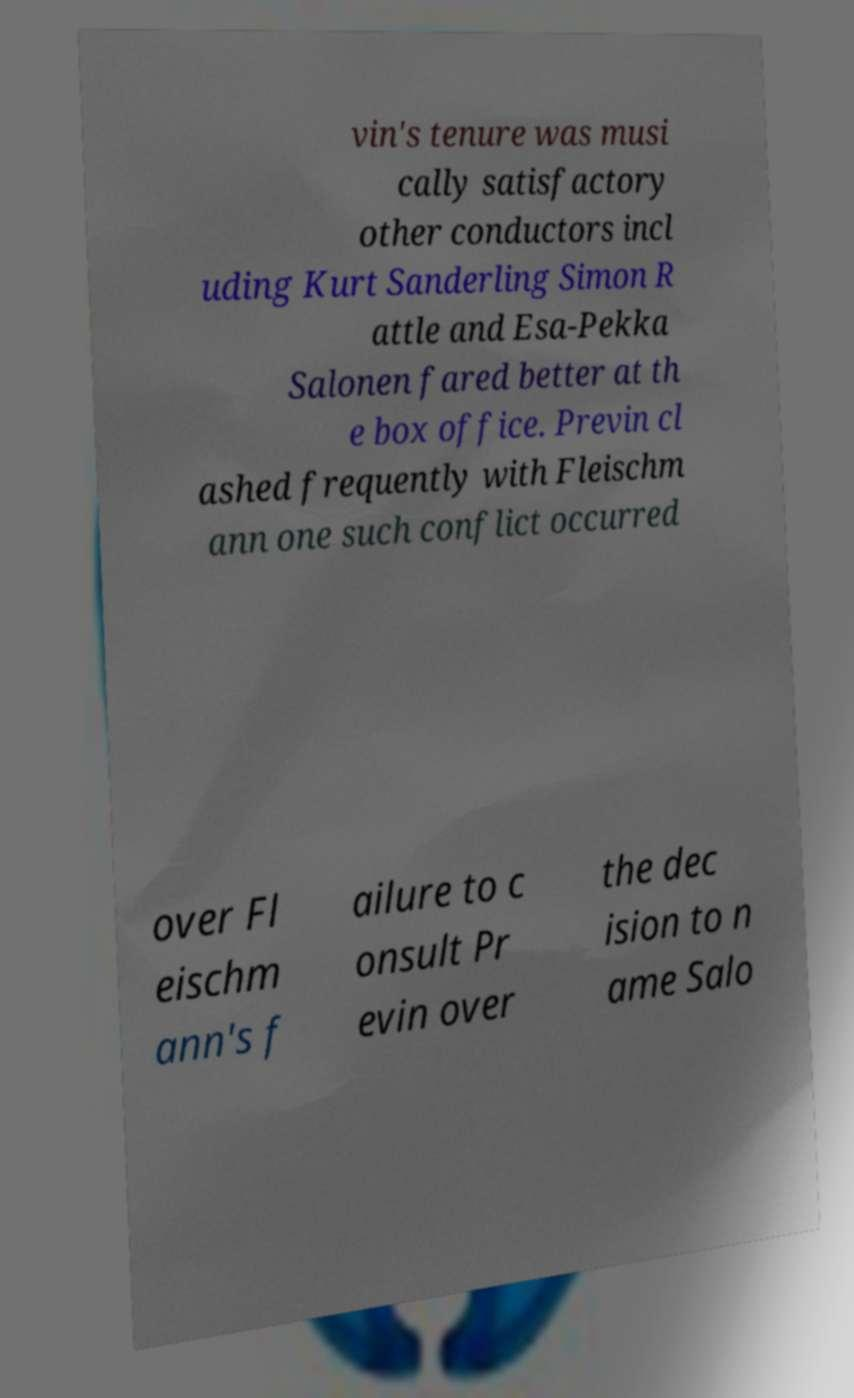Please identify and transcribe the text found in this image. vin's tenure was musi cally satisfactory other conductors incl uding Kurt Sanderling Simon R attle and Esa-Pekka Salonen fared better at th e box office. Previn cl ashed frequently with Fleischm ann one such conflict occurred over Fl eischm ann's f ailure to c onsult Pr evin over the dec ision to n ame Salo 